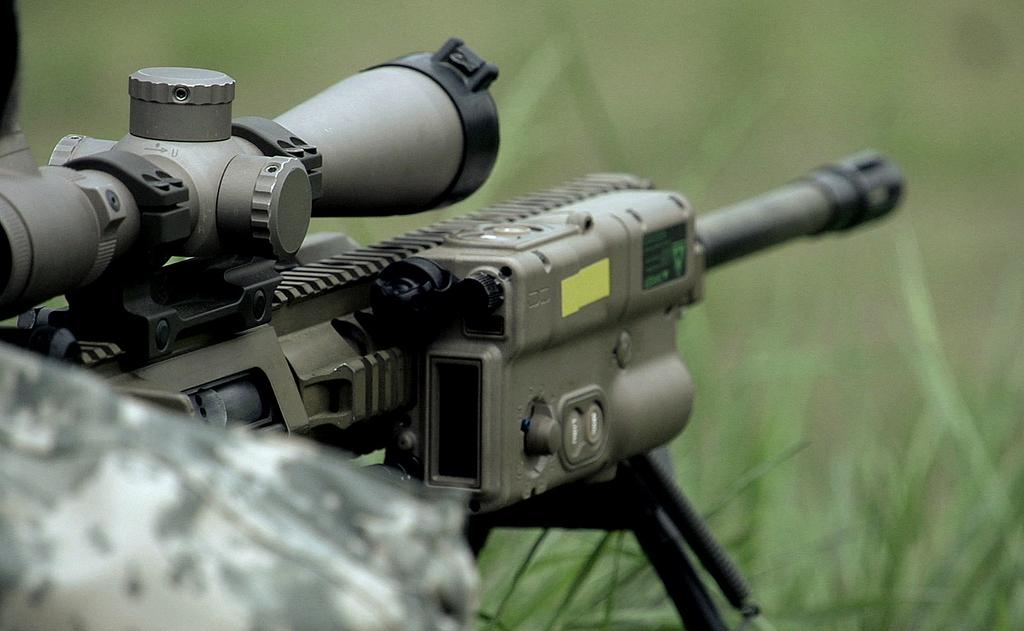What object is placed on a stand in the image? There is a gun on a stand in the image. How would you describe the background of the image? The background of the image is blurred. What type of terrain can be seen at the bottom of the image? There is grass visible at the bottom of the image. Can you identify any part of a person in the image? Yes, a person's shoulder is visible on the left side of the image. What type of feather can be seen falling in the image? There is no feather visible in the image. Is the image taken during winter, given the presence of snow? The image does not show any snow or winter-related elements, so it cannot be determined if it was taken during winter. 